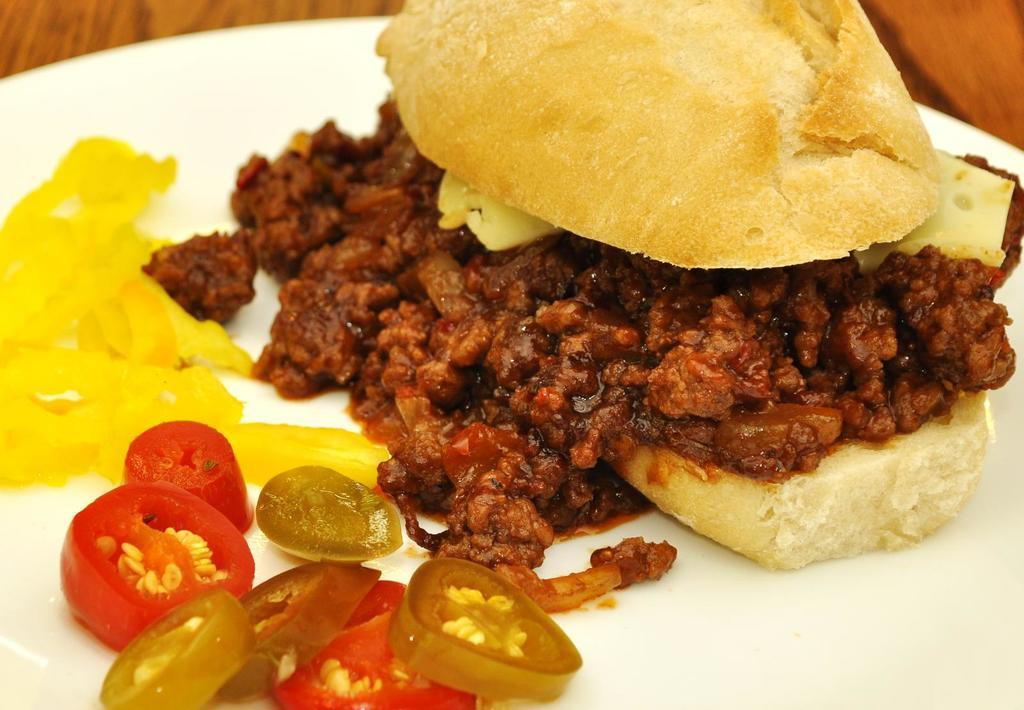What type of food can be seen in the image? The image contains food, but the specific type is not mentioned in the facts. What colors are present in the food? The food has brown, red, and yellow colors. What color is the plate containing the food? The plate is white. Where is the plate located? The plate is on a table. What is the color of the table? The table is brown. Can you see the sun in the image? The facts provided do not mention the presence of the sun in the image. What is the neck of the person eating the food like in the image? There is no person present in the image, so we cannot describe their neck. 